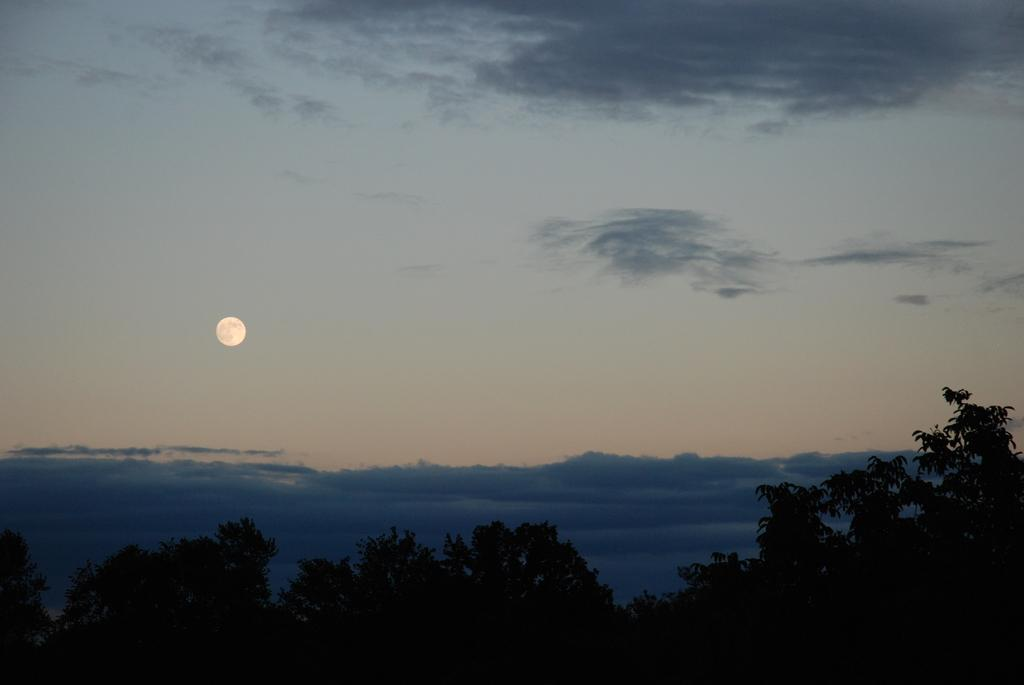What celestial body can be seen in the sky in the image? The moon is visible in the sky in the image. What else is present in the sky besides the moon? There are clouds in the sky in the image. What type of vegetation is at the bottom of the image? There are trees at the bottom of the image. What sense is being used by the jellyfish in the image? There are no jellyfish present in the image, so it is not possible to determine which sense they might be using. 